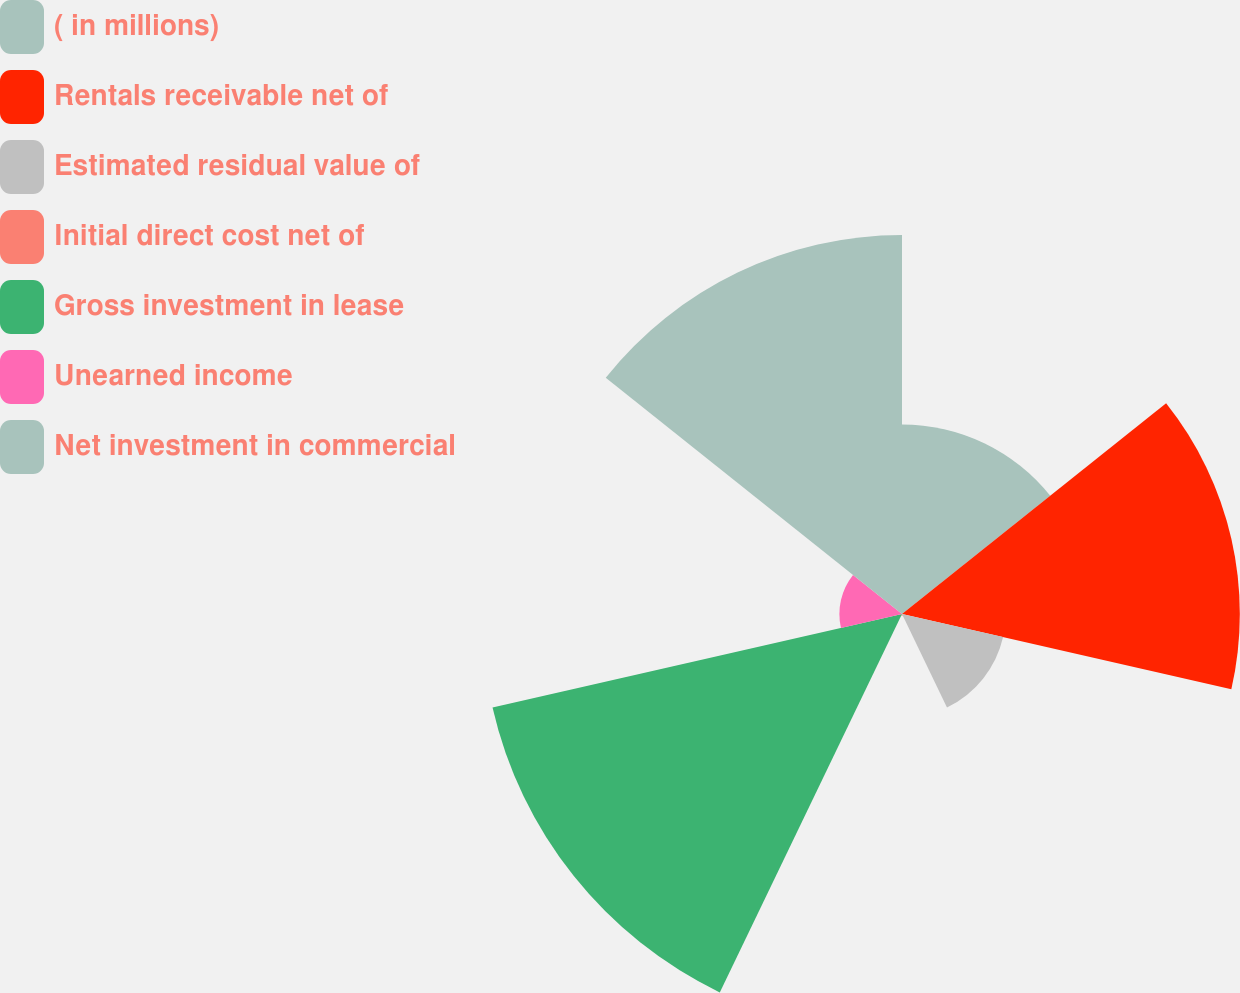Convert chart to OTSL. <chart><loc_0><loc_0><loc_500><loc_500><pie_chart><fcel>( in millions)<fcel>Rentals receivable net of<fcel>Estimated residual value of<fcel>Initial direct cost net of<fcel>Gross investment in lease<fcel>Unearned income<fcel>Net investment in commercial<nl><fcel>12.69%<fcel>22.61%<fcel>6.94%<fcel>0.11%<fcel>28.11%<fcel>4.19%<fcel>25.36%<nl></chart> 